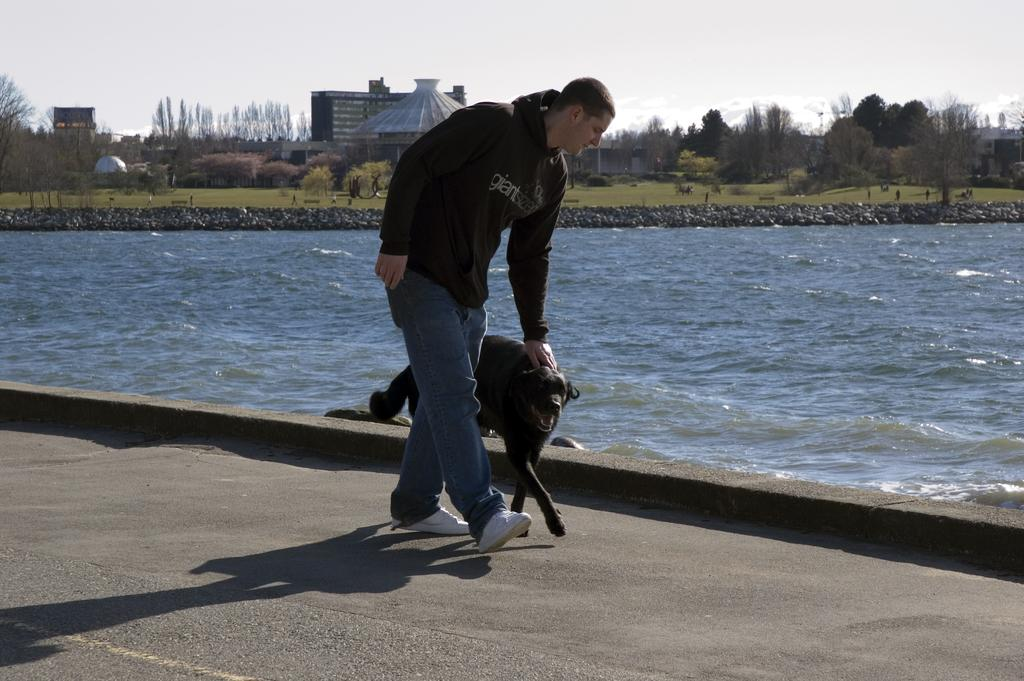Where was the image taken? The image is taken outdoors. What is the man in the center of the image doing? The man is walking in the center of the image. What is the man holding? The man is holding a dog. What can be seen in the background of the image? There is a river, trees, buildings, and the sky visible in the background of the image. Can you tell me how many kitties are sitting on the nest in the image? There are no kitties or nests present in the image. What language is the man talking to the dog in the image? The image does not provide any information about the language being spoken, nor does it show the man talking to the dog. 